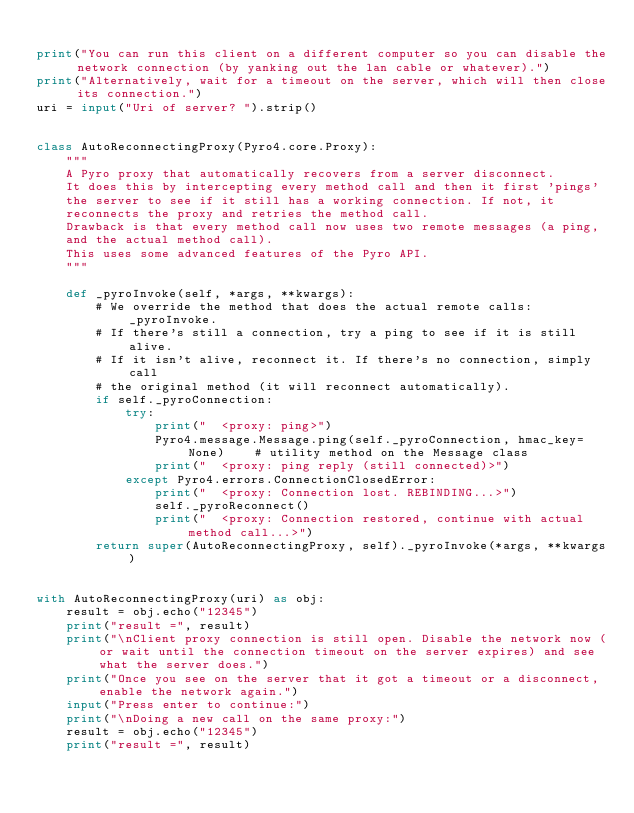Convert code to text. <code><loc_0><loc_0><loc_500><loc_500><_Python_>
print("You can run this client on a different computer so you can disable the network connection (by yanking out the lan cable or whatever).")
print("Alternatively, wait for a timeout on the server, which will then close its connection.")
uri = input("Uri of server? ").strip()


class AutoReconnectingProxy(Pyro4.core.Proxy):
    """
    A Pyro proxy that automatically recovers from a server disconnect.
    It does this by intercepting every method call and then it first 'pings'
    the server to see if it still has a working connection. If not, it
    reconnects the proxy and retries the method call.
    Drawback is that every method call now uses two remote messages (a ping,
    and the actual method call).
    This uses some advanced features of the Pyro API.
    """

    def _pyroInvoke(self, *args, **kwargs):
        # We override the method that does the actual remote calls: _pyroInvoke.
        # If there's still a connection, try a ping to see if it is still alive.
        # If it isn't alive, reconnect it. If there's no connection, simply call
        # the original method (it will reconnect automatically).
        if self._pyroConnection:
            try:
                print("  <proxy: ping>")
                Pyro4.message.Message.ping(self._pyroConnection, hmac_key=None)    # utility method on the Message class
                print("  <proxy: ping reply (still connected)>")
            except Pyro4.errors.ConnectionClosedError:
                print("  <proxy: Connection lost. REBINDING...>")
                self._pyroReconnect()
                print("  <proxy: Connection restored, continue with actual method call...>")
        return super(AutoReconnectingProxy, self)._pyroInvoke(*args, **kwargs)


with AutoReconnectingProxy(uri) as obj:
    result = obj.echo("12345")
    print("result =", result)
    print("\nClient proxy connection is still open. Disable the network now (or wait until the connection timeout on the server expires) and see what the server does.")
    print("Once you see on the server that it got a timeout or a disconnect, enable the network again.")
    input("Press enter to continue:")
    print("\nDoing a new call on the same proxy:")
    result = obj.echo("12345")
    print("result =", result)
</code> 